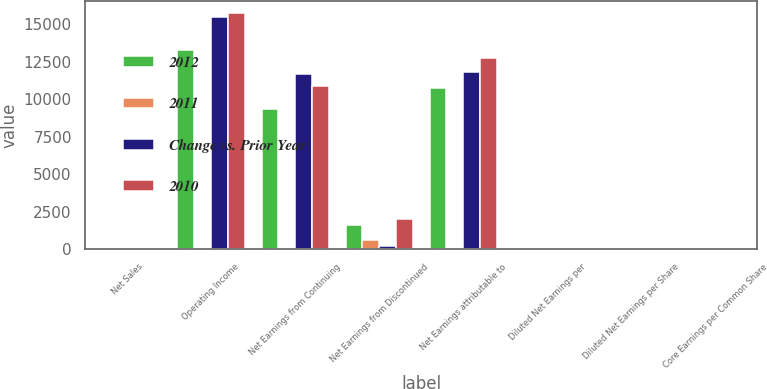<chart> <loc_0><loc_0><loc_500><loc_500><stacked_bar_chart><ecel><fcel>Net Sales<fcel>Operating Income<fcel>Net Earnings from Continuing<fcel>Net Earnings from Discontinued<fcel>Net Earnings attributable to<fcel>Diluted Net Earnings per<fcel>Diluted Net Earnings per Share<fcel>Core Earnings per Common Share<nl><fcel>2012<fcel>19<fcel>13292<fcel>9317<fcel>1587<fcel>10756<fcel>3.66<fcel>3.12<fcel>3.85<nl><fcel>2011<fcel>3<fcel>14<fcel>20<fcel>593<fcel>9<fcel>7<fcel>19<fcel>1<nl><fcel>Change vs. Prior Year<fcel>19<fcel>15495<fcel>11698<fcel>229<fcel>11797<fcel>3.93<fcel>3.85<fcel>3.87<nl><fcel>2010<fcel>19<fcel>15732<fcel>10851<fcel>1995<fcel>12736<fcel>4.11<fcel>3.47<fcel>3.61<nl></chart> 